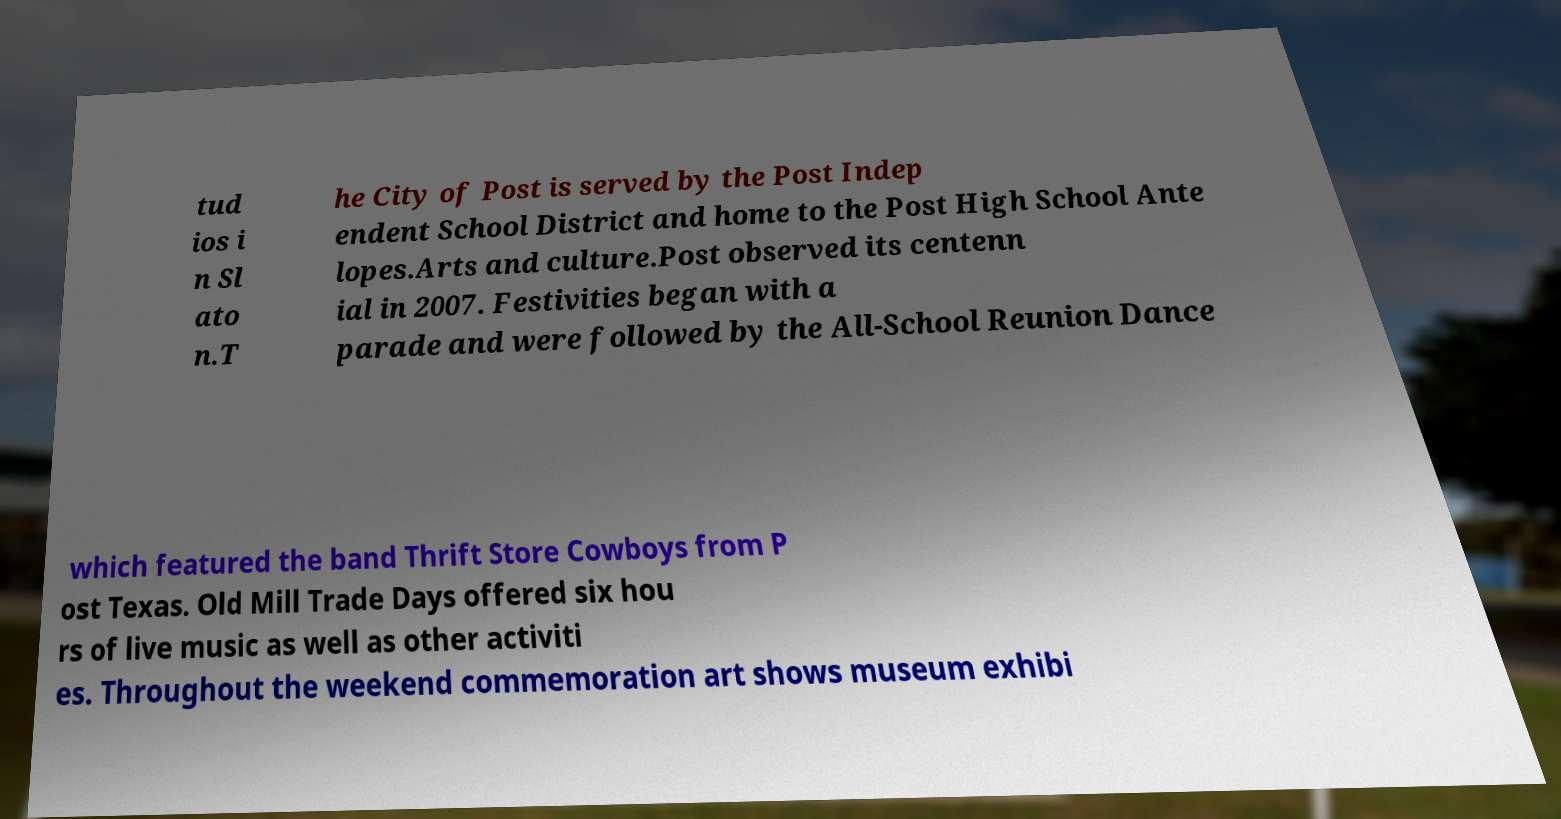I need the written content from this picture converted into text. Can you do that? tud ios i n Sl ato n.T he City of Post is served by the Post Indep endent School District and home to the Post High School Ante lopes.Arts and culture.Post observed its centenn ial in 2007. Festivities began with a parade and were followed by the All-School Reunion Dance which featured the band Thrift Store Cowboys from P ost Texas. Old Mill Trade Days offered six hou rs of live music as well as other activiti es. Throughout the weekend commemoration art shows museum exhibi 